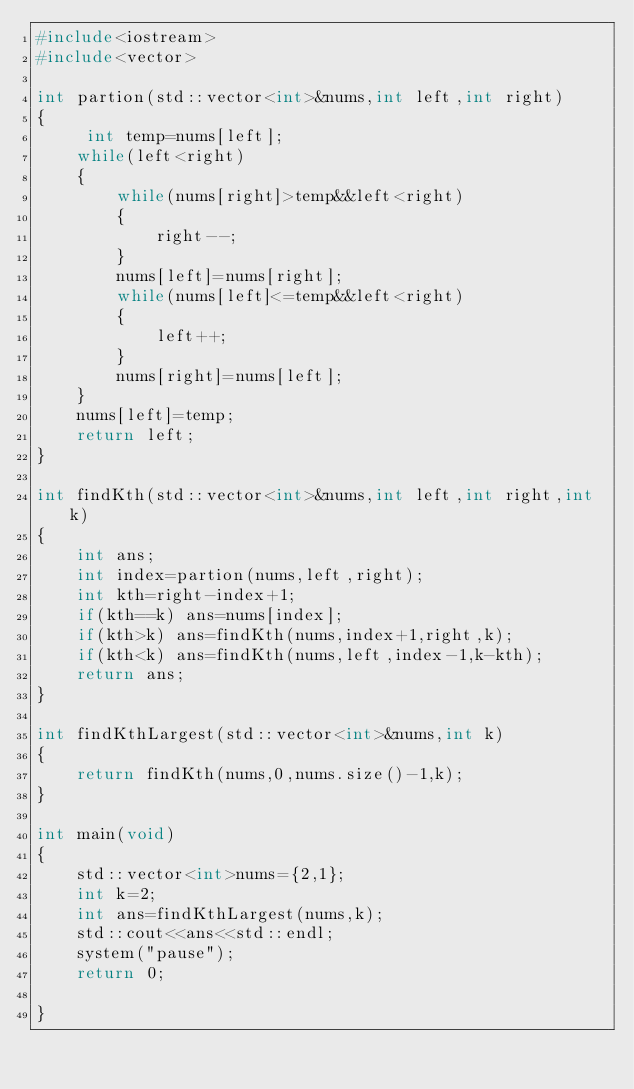<code> <loc_0><loc_0><loc_500><loc_500><_C++_>#include<iostream>
#include<vector>

int partion(std::vector<int>&nums,int left,int right)
{
     int temp=nums[left];
    while(left<right)
    {
        while(nums[right]>temp&&left<right) 
        {
            right--;
        }
        nums[left]=nums[right];
        while(nums[left]<=temp&&left<right) 
        {
            left++;
        }
        nums[right]=nums[left];
    }
    nums[left]=temp;
    return left;
}

int findKth(std::vector<int>&nums,int left,int right,int k)
{
    int ans;
    int index=partion(nums,left,right);
    int kth=right-index+1;
    if(kth==k) ans=nums[index];
    if(kth>k) ans=findKth(nums,index+1,right,k);
    if(kth<k) ans=findKth(nums,left,index-1,k-kth);
    return ans;
}

int findKthLargest(std::vector<int>&nums,int k)
{
    return findKth(nums,0,nums.size()-1,k);
}

int main(void)
{
    std::vector<int>nums={2,1};
    int k=2;
    int ans=findKthLargest(nums,k);
    std::cout<<ans<<std::endl;
    system("pause");
    return 0;

}</code> 